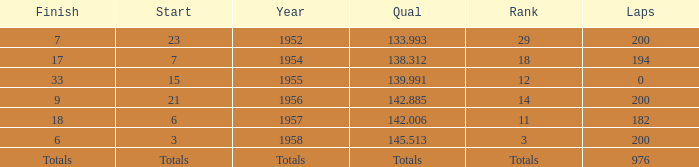Can you give me this table as a dict? {'header': ['Finish', 'Start', 'Year', 'Qual', 'Rank', 'Laps'], 'rows': [['7', '23', '1952', '133.993', '29', '200'], ['17', '7', '1954', '138.312', '18', '194'], ['33', '15', '1955', '139.991', '12', '0'], ['9', '21', '1956', '142.885', '14', '200'], ['18', '6', '1957', '142.006', '11', '182'], ['6', '3', '1958', '145.513', '3', '200'], ['Totals', 'Totals', 'Totals', 'Totals', 'Totals', '976']]} What place did Jimmy Reece start from when he ranked 12? 15.0. 